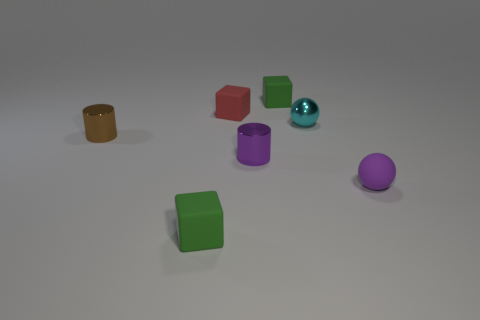Add 1 tiny balls. How many objects exist? 8 Subtract all cubes. How many objects are left? 4 Add 6 large blue rubber blocks. How many large blue rubber blocks exist? 6 Subtract 0 gray cylinders. How many objects are left? 7 Subtract all small red rubber blocks. Subtract all shiny cylinders. How many objects are left? 4 Add 2 small purple rubber spheres. How many small purple rubber spheres are left? 3 